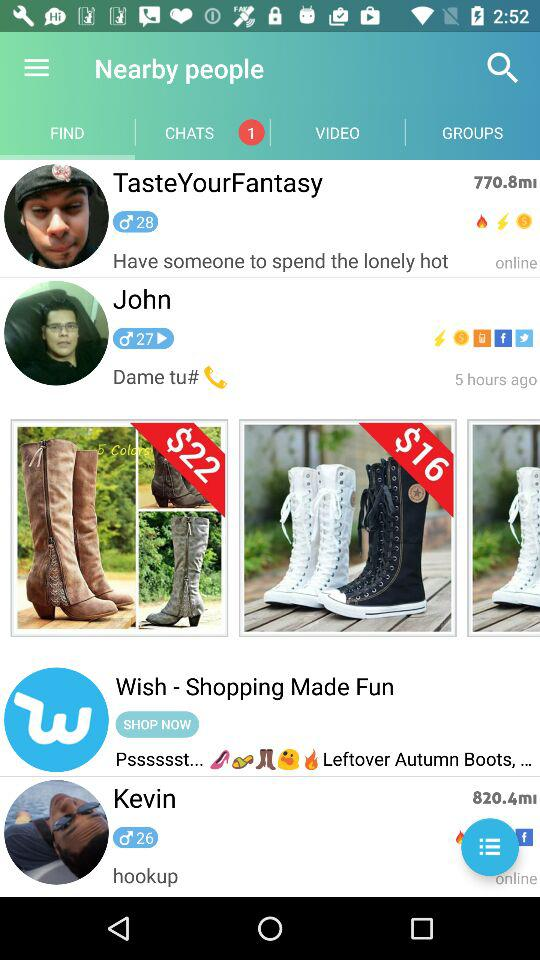On which tab of the application are we? You are on the "FIND" tab of the application. 